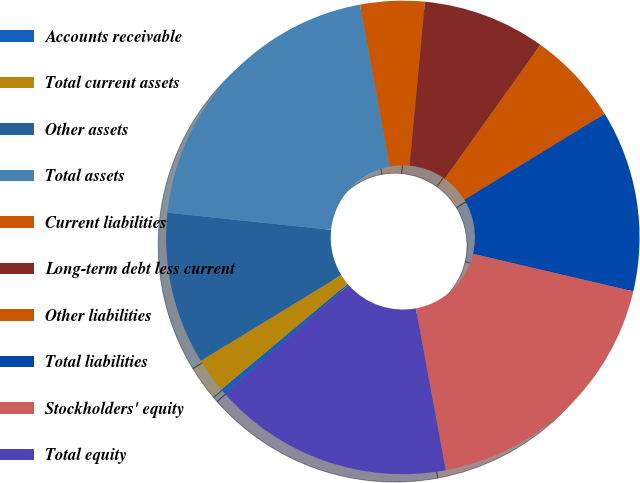<chart> <loc_0><loc_0><loc_500><loc_500><pie_chart><fcel>Accounts receivable<fcel>Total current assets<fcel>Other assets<fcel>Total assets<fcel>Current liabilities<fcel>Long-term debt less current<fcel>Other liabilities<fcel>Total liabilities<fcel>Stockholders' equity<fcel>Total equity<nl><fcel>0.37%<fcel>2.38%<fcel>10.39%<fcel>20.44%<fcel>4.38%<fcel>8.39%<fcel>6.38%<fcel>12.4%<fcel>18.44%<fcel>16.43%<nl></chart> 